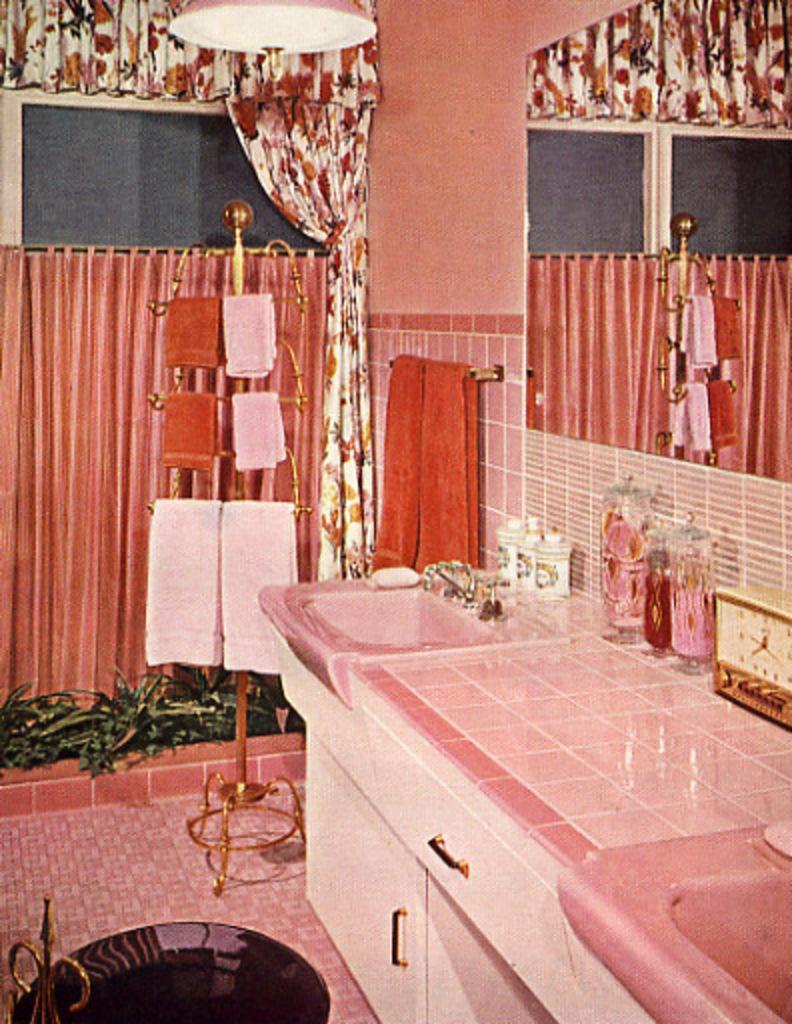Can you describe this image briefly? In this image there is a cabinet having sink tap, bottles, clock on it. There is a rod having a cloth is attached to the wall. Beside the cabinet there is a standing having few clothes on it. There are few plants. Behind there is a curtain to the window. 